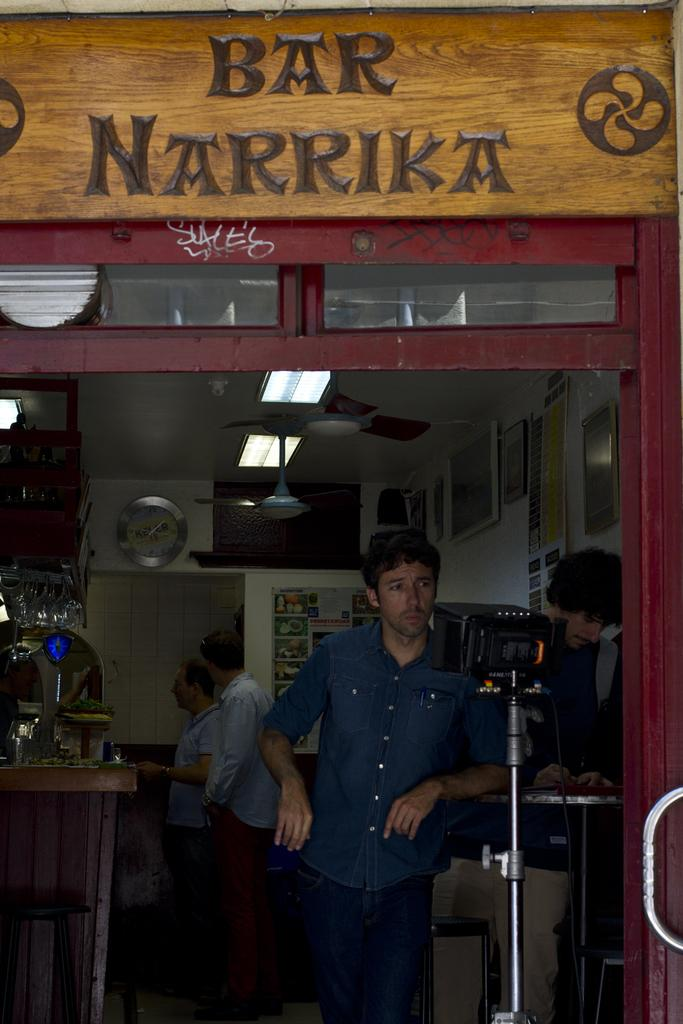<image>
Give a short and clear explanation of the subsequent image. a storefront of Bar Narrika with a man leaning on the bar 